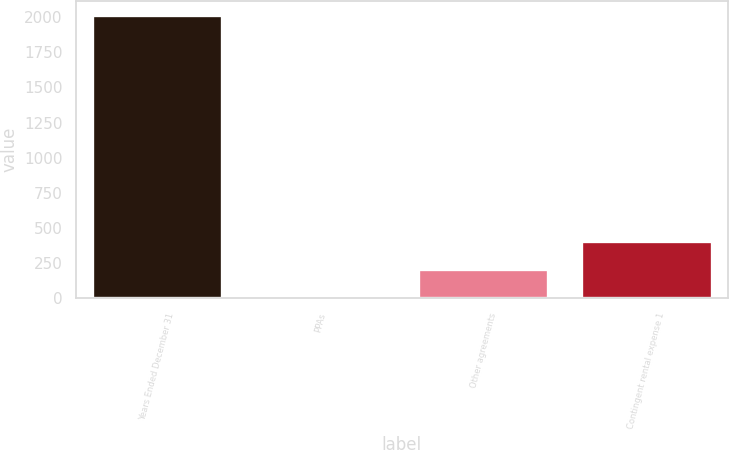Convert chart. <chart><loc_0><loc_0><loc_500><loc_500><bar_chart><fcel>Years Ended December 31<fcel>PPAs<fcel>Other agreements<fcel>Contingent rental expense 1<nl><fcel>2012<fcel>6<fcel>206.6<fcel>407.2<nl></chart> 